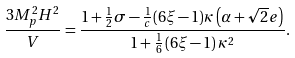Convert formula to latex. <formula><loc_0><loc_0><loc_500><loc_500>\frac { 3 M _ { p } ^ { 2 } H ^ { 2 } } { V } = \frac { 1 + \frac { 1 } { 2 } \sigma - \frac { 1 } { c } ( 6 \xi - 1 ) \kappa \left ( \alpha + \sqrt { 2 } e \right ) } { 1 + \frac { 1 } { 6 } \left ( 6 \xi - 1 \right ) \kappa ^ { 2 } } .</formula> 